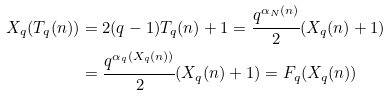<formula> <loc_0><loc_0><loc_500><loc_500>X _ { q } ( T _ { q } ( n ) ) & = 2 ( q - 1 ) T _ { q } ( n ) + 1 = \cfrac { q ^ { \alpha _ { N } ( n ) } } { 2 } ( X _ { q } ( n ) + 1 ) \\ & = \cfrac { q ^ { \alpha _ { q } ( X _ { q } ( n ) ) } } { 2 } ( X _ { q } ( n ) + 1 ) = F _ { q } ( X _ { q } ( n ) )</formula> 